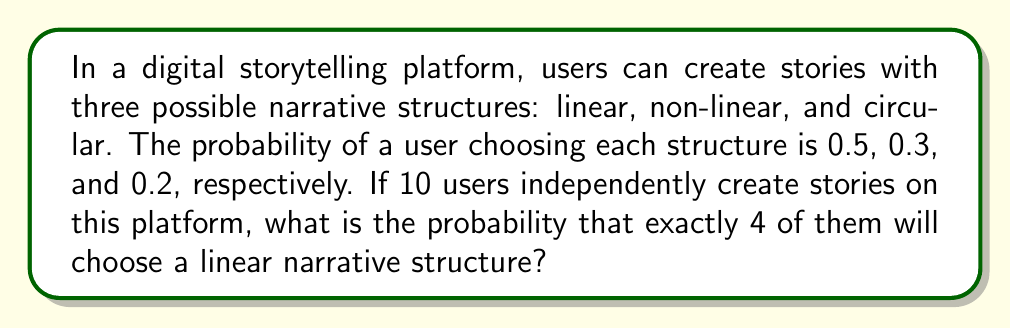Help me with this question. To solve this problem, we'll use the binomial probability distribution, as we're dealing with a fixed number of independent trials (10 users) with two possible outcomes for each trial (linear structure or not linear structure).

Step 1: Identify the components of the binomial distribution:
- $n$ = number of trials = 10
- $p$ = probability of success (choosing linear structure) = 0.5
- $k$ = number of successes we're interested in = 4

Step 2: Use the binomial probability formula:

$$ P(X = k) = \binom{n}{k} p^k (1-p)^{n-k} $$

Where $\binom{n}{k}$ is the binomial coefficient, calculated as:

$$ \binom{n}{k} = \frac{n!}{k!(n-k)!} $$

Step 3: Calculate the binomial coefficient:

$$ \binom{10}{4} = \frac{10!}{4!(10-4)!} = \frac{10!}{4!6!} = 210 $$

Step 4: Plug the values into the binomial probability formula:

$$ P(X = 4) = 210 \cdot (0.5)^4 \cdot (1-0.5)^{10-4} $$

Step 5: Simplify and calculate:

$$ P(X = 4) = 210 \cdot (0.5)^4 \cdot (0.5)^6 $$
$$ P(X = 4) = 210 \cdot 0.0625 \cdot 0.015625 $$
$$ P(X = 4) = 0.2050781250 $$

Therefore, the probability that exactly 4 out of 10 users will choose a linear narrative structure is approximately 0.2051 or 20.51%.
Answer: 0.2051 